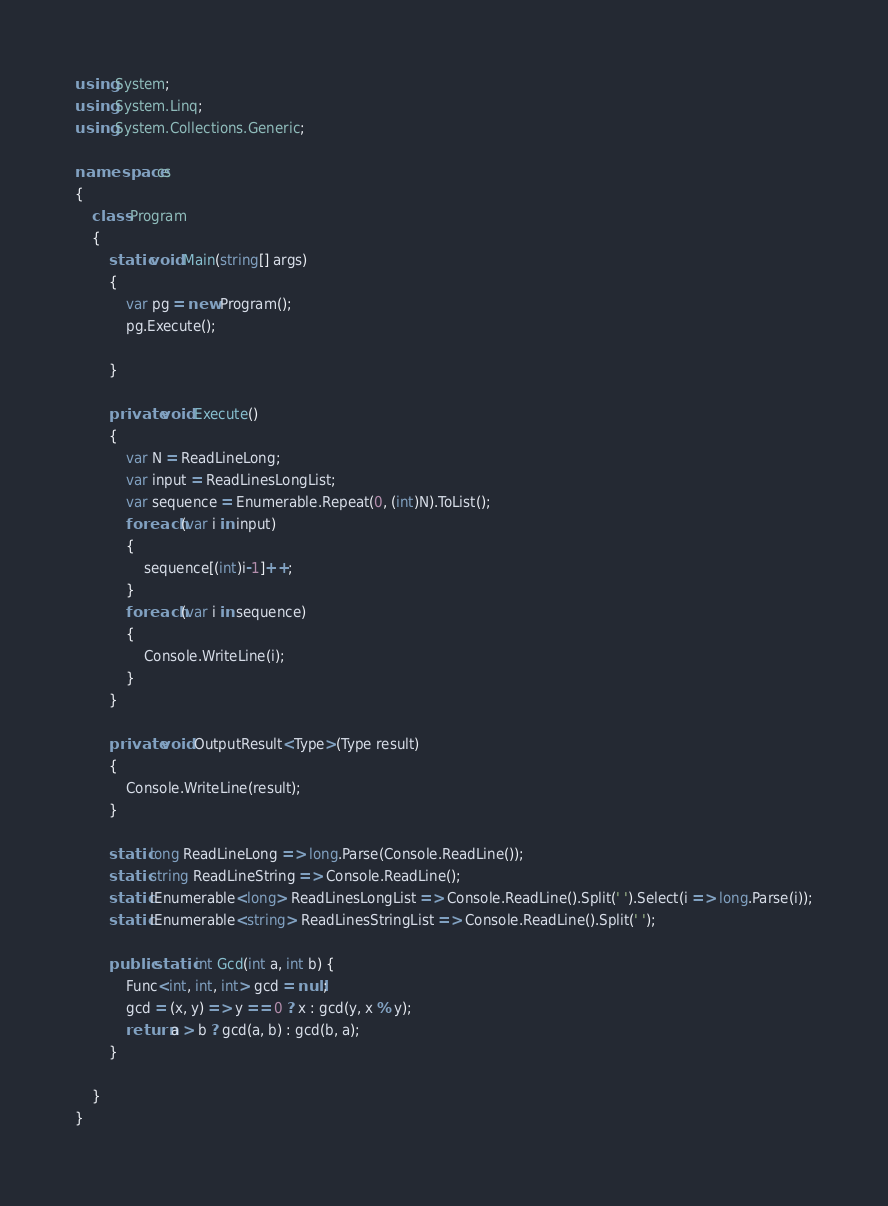<code> <loc_0><loc_0><loc_500><loc_500><_C#_>using System;
using System.Linq;
using System.Collections.Generic;

namespace cs
{
    class Program
    {
        static void Main(string[] args)
        {
            var pg = new Program();
            pg.Execute();

        }

        private void Execute()
        {
            var N = ReadLineLong;
            var input = ReadLinesLongList;
            var sequence = Enumerable.Repeat(0, (int)N).ToList();
            foreach (var i in input)
            {
                sequence[(int)i-1]++;
            }
            foreach (var i in sequence)
            {
                Console.WriteLine(i);
            }
        }

        private void OutputResult<Type>(Type result)
        {
            Console.WriteLine(result);
        }

        static long ReadLineLong => long.Parse(Console.ReadLine());
        static string ReadLineString => Console.ReadLine();
        static IEnumerable<long> ReadLinesLongList => Console.ReadLine().Split(' ').Select(i => long.Parse(i));
        static IEnumerable<string> ReadLinesStringList => Console.ReadLine().Split(' ');

        public static int Gcd(int a, int b) {
            Func<int, int, int> gcd = null;
            gcd = (x, y) => y == 0 ? x : gcd(y, x % y);
            return a > b ? gcd(a, b) : gcd(b, a);
        }

    }
}
</code> 